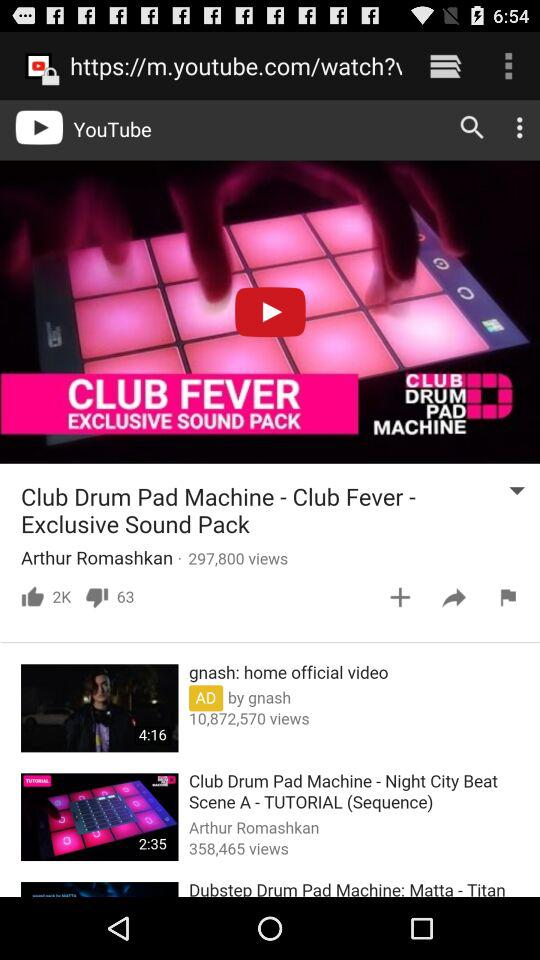How many likes are there for "Club Drum Pad Machine - Club Fever"? There are 2K likes. 